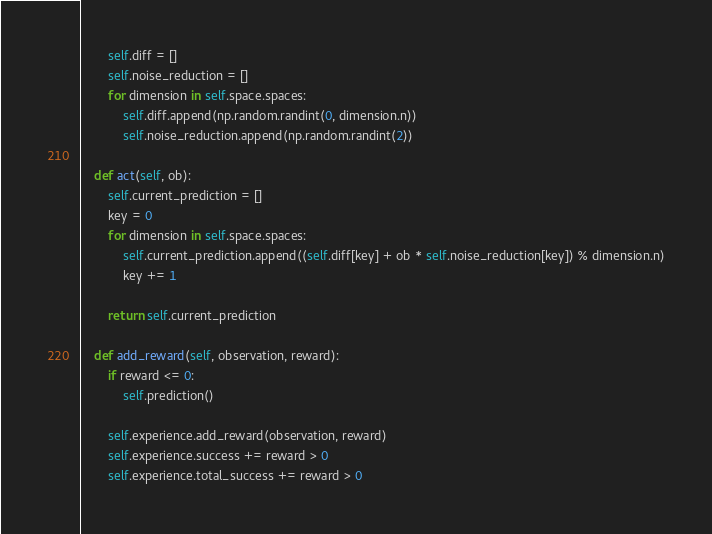<code> <loc_0><loc_0><loc_500><loc_500><_Python_>        self.diff = []
        self.noise_reduction = []
        for dimension in self.space.spaces:
            self.diff.append(np.random.randint(0, dimension.n))
            self.noise_reduction.append(np.random.randint(2))

    def act(self, ob):
        self.current_prediction = []
        key = 0
        for dimension in self.space.spaces:
            self.current_prediction.append((self.diff[key] + ob * self.noise_reduction[key]) % dimension.n)
            key += 1

        return self.current_prediction

    def add_reward(self, observation, reward):
        if reward <= 0:
            self.prediction()

        self.experience.add_reward(observation, reward)
        self.experience.success += reward > 0
        self.experience.total_success += reward > 0
</code> 